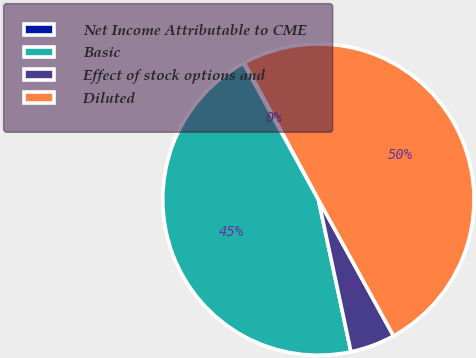<chart> <loc_0><loc_0><loc_500><loc_500><pie_chart><fcel>Net Income Attributable to CME<fcel>Basic<fcel>Effect of stock options and<fcel>Diluted<nl><fcel>0.13%<fcel>45.34%<fcel>4.66%<fcel>49.87%<nl></chart> 